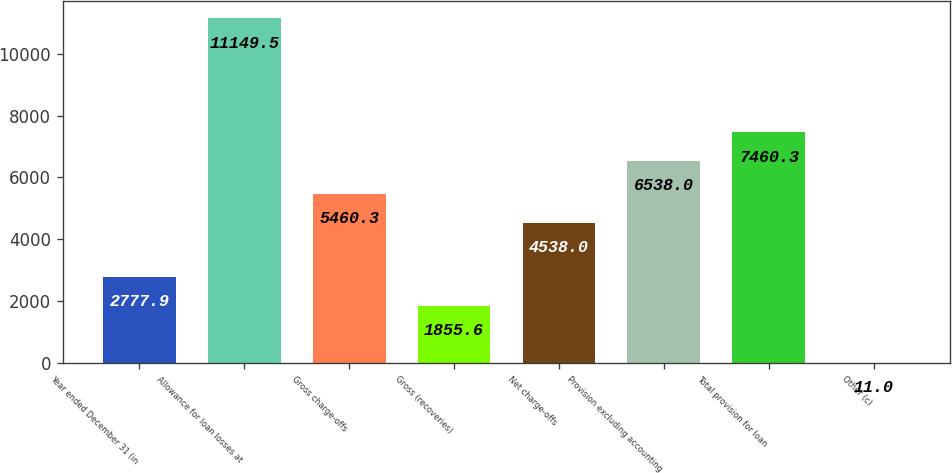Convert chart. <chart><loc_0><loc_0><loc_500><loc_500><bar_chart><fcel>Year ended December 31 (in<fcel>Allowance for loan losses at<fcel>Gross charge-offs<fcel>Gross (recoveries)<fcel>Net charge-offs<fcel>Provision excluding accounting<fcel>Total provision for loan<fcel>Other (c)<nl><fcel>2777.9<fcel>11149.5<fcel>5460.3<fcel>1855.6<fcel>4538<fcel>6538<fcel>7460.3<fcel>11<nl></chart> 